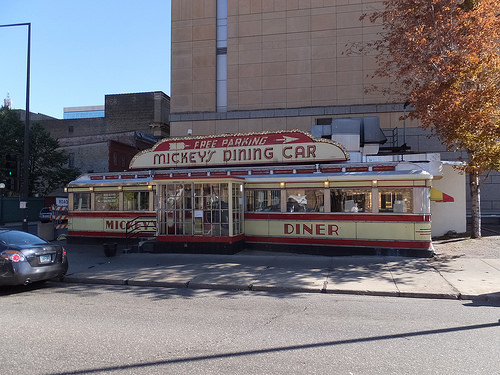<image>
Is there a car in front of the sidewalk? Yes. The car is positioned in front of the sidewalk, appearing closer to the camera viewpoint. Where is the street in relation to the building? Is it in front of the building? Yes. The street is positioned in front of the building, appearing closer to the camera viewpoint. 